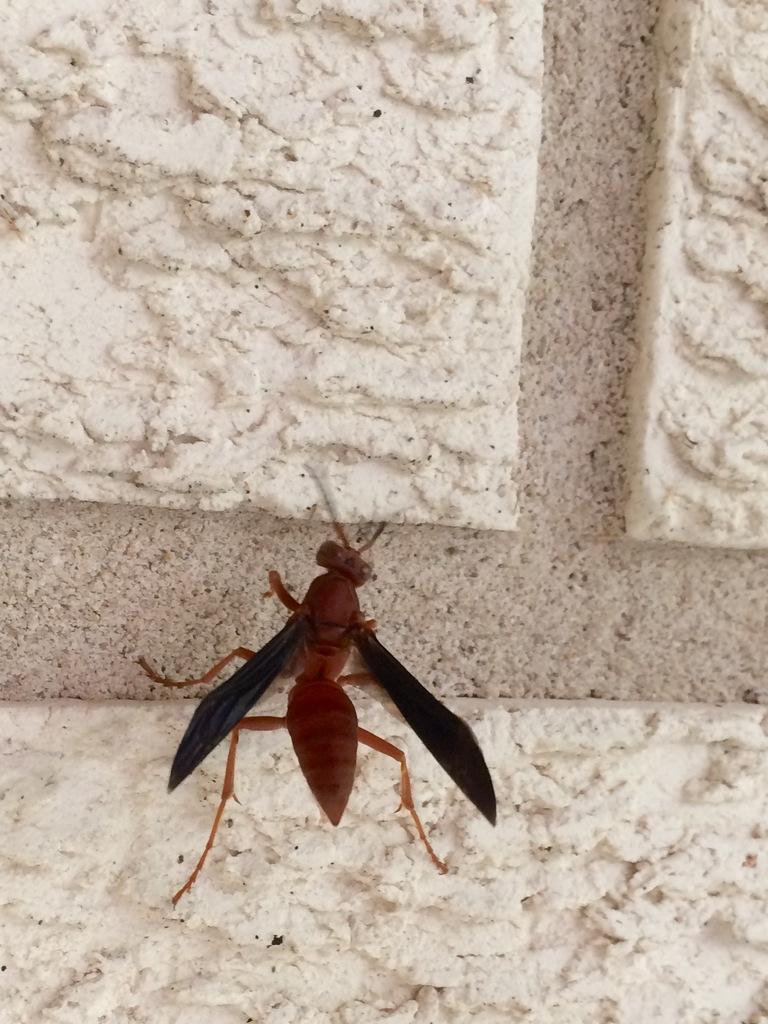Can you describe this image briefly? In this image in the center there is an insect, and in the background there is wall. 